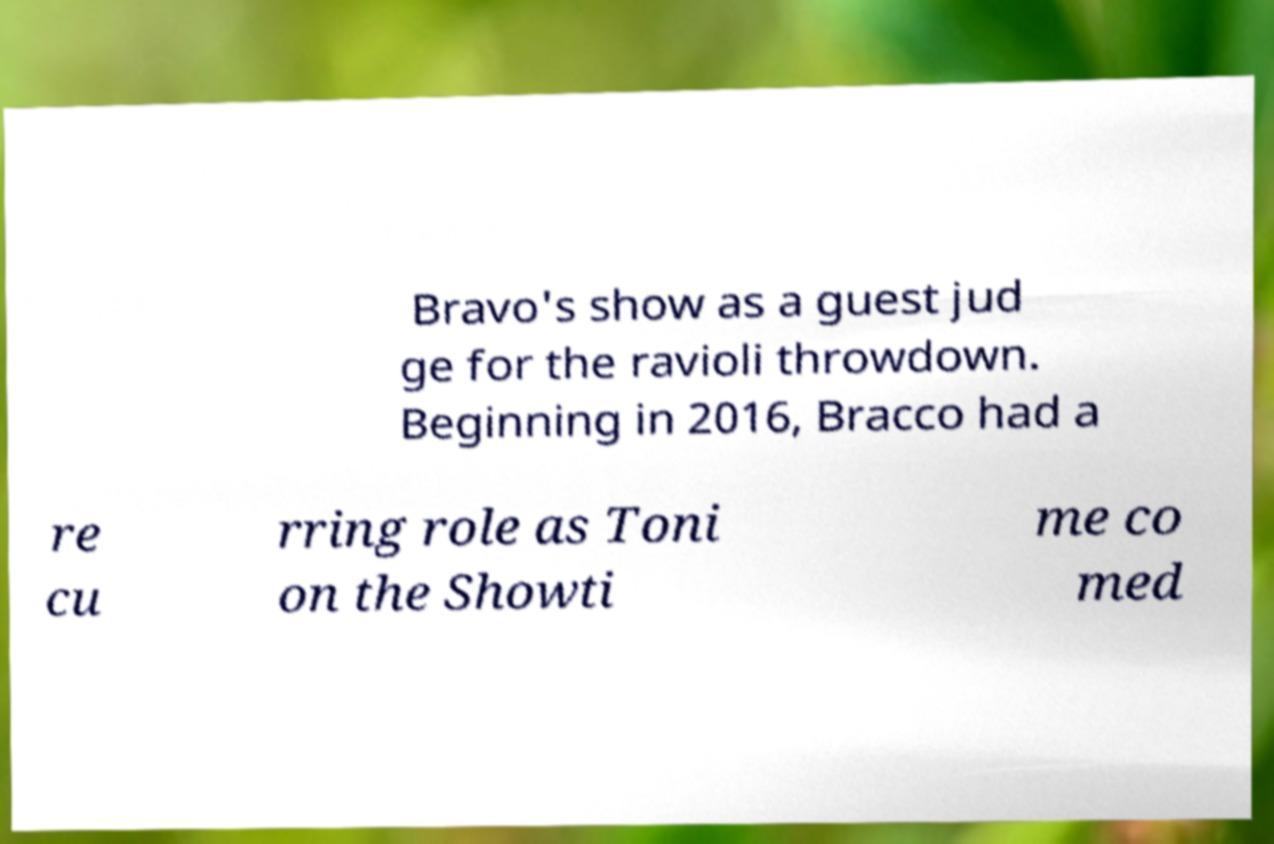Can you accurately transcribe the text from the provided image for me? Bravo's show as a guest jud ge for the ravioli throwdown. Beginning in 2016, Bracco had a re cu rring role as Toni on the Showti me co med 